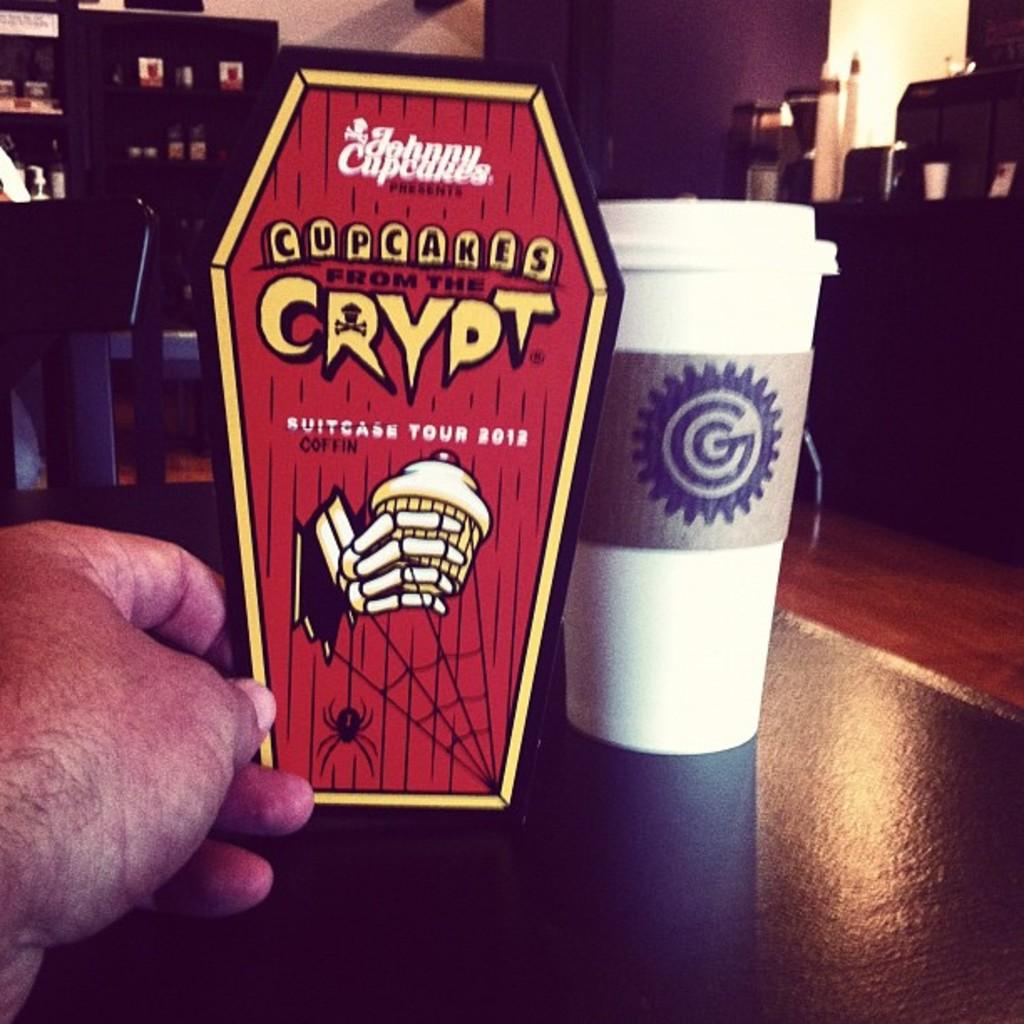What is the main object in the image? There is a glass in the image. Whose hand is visible in the image? A person's hand is visible in the image. What is the color of the surface on which other objects are placed? The surface is black. What can be seen in the background of the image? There is a wall and other objects visible in the background of the image. What degree of difficulty is the person attempting to balance on the glass in the image? There is no indication in the image that the person is attempting to balance on the glass, and therefore no degree of difficulty can be determined. 